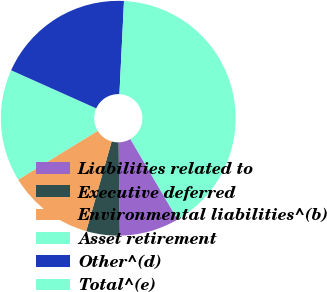Convert chart to OTSL. <chart><loc_0><loc_0><loc_500><loc_500><pie_chart><fcel>Liabilities related to<fcel>Executive deferred<fcel>Environmental liabilities^(b)<fcel>Asset retirement<fcel>Other^(d)<fcel>Total^(e)<nl><fcel>8.23%<fcel>4.61%<fcel>11.84%<fcel>15.46%<fcel>19.08%<fcel>40.78%<nl></chart> 